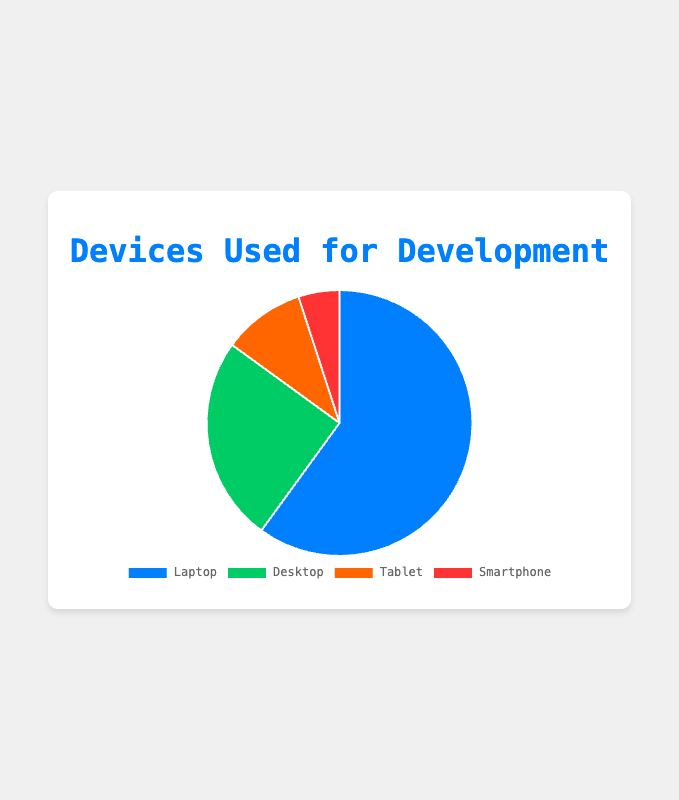What percentage of developers use Tablets for development? To determine the percentage of developers who use Tablets, you can directly look at the labeled data in the Pie chart for Tablets. The label shows a percentage of 10%.
Answer: 10% How many times more developers use Laptops than Smartphones for development? According to the chart, 60% use Laptops and 5% use Smartphones. To find how many times more developers use Laptops than Smartphones, divide 60 by 5.
Answer: 12 times What is the combined percentage of developers using Desktop and Smartphones for development? To find the combined percentage of developers using Desktop and Smartphones, add the percentage of Desktop users (25%) and Smartphone users (5%). The sum is 25% + 5% = 30%.
Answer: 30% Which device is the least used for development? By visually inspecting the slices of the Pie chart, the smallest slice corresponds to the Smartphone category, which is 5%. Therefore, Smartphones are the least used device for development.
Answer: Smartphone What is the difference in percentage between developers using Laptops and Tablets for development? The percentage of developers using Laptops is 60%, and for Tablets, it is 10%. Subtracting these gives 60% - 10% = 50%.
Answer: 50% What percentage of developers use devices other than Laptops for development? To find the percentage that uses devices other than Laptops, sum the percentages of Desktop, Tablet, and Smartphone users: 25% + 10% + 5% = 40%.
Answer: 40% Are there more developers using Desktops or Tablets for development, and by what percentage? Comparing the data, 25% use Desktops, and 10% use Tablets. The difference is 25% - 10% = 15%. Hence, more developers use Desktops than Tablets by 15%.
Answer: Desktops by 15% Which device category has the second largest percentage of users? By looking at the Pie chart, the second-largest slice corresponds to the Desktop category, which is 25%.
Answer: Desktop What fraction of developers use Smartphones for development compared to the total? Since 5% of developers use Smartphones, the fraction can be expressed as 5/100 or simplified to 1/20.
Answer: 1/20 